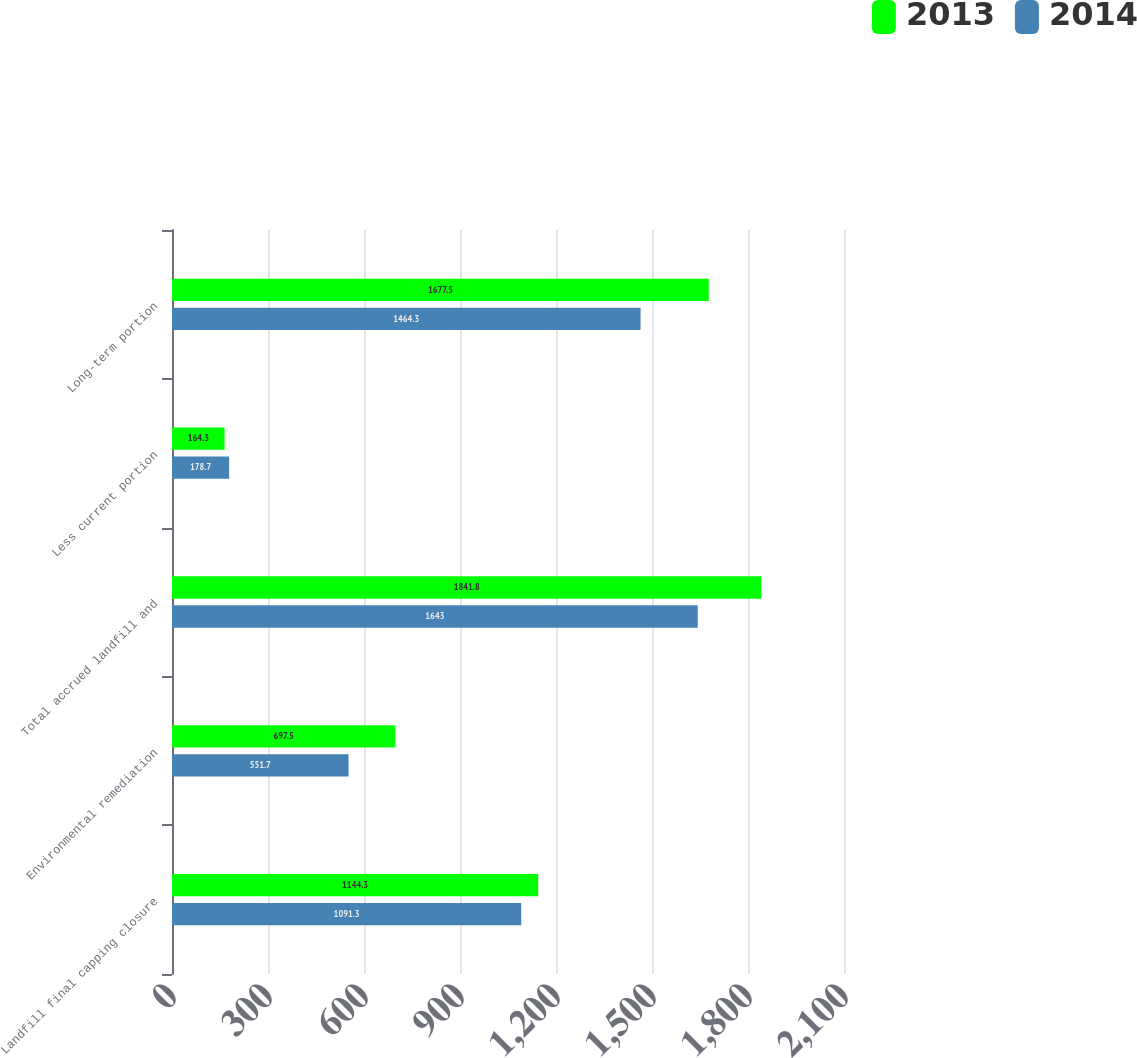Convert chart to OTSL. <chart><loc_0><loc_0><loc_500><loc_500><stacked_bar_chart><ecel><fcel>Landfill final capping closure<fcel>Environmental remediation<fcel>Total accrued landfill and<fcel>Less current portion<fcel>Long-term portion<nl><fcel>2013<fcel>1144.3<fcel>697.5<fcel>1841.8<fcel>164.3<fcel>1677.5<nl><fcel>2014<fcel>1091.3<fcel>551.7<fcel>1643<fcel>178.7<fcel>1464.3<nl></chart> 